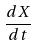Convert formula to latex. <formula><loc_0><loc_0><loc_500><loc_500>\frac { d X } { d t }</formula> 